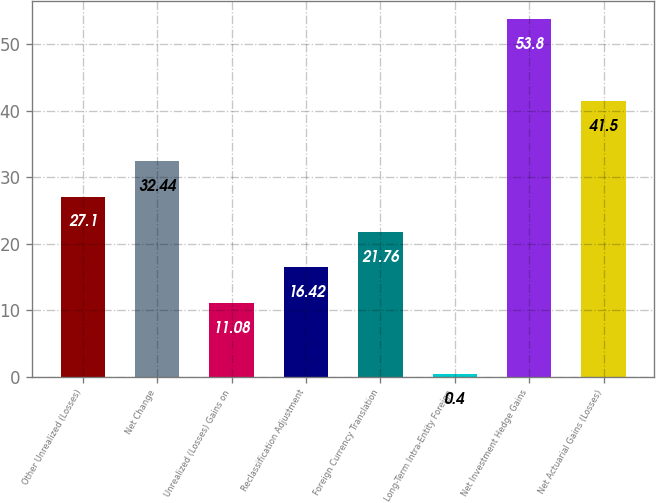<chart> <loc_0><loc_0><loc_500><loc_500><bar_chart><fcel>Other Unrealized (Losses)<fcel>Net Change<fcel>Unrealized (Losses) Gains on<fcel>Reclassification Adjustment<fcel>Foreign Currency Translation<fcel>Long-Term Intra-Entity Foreign<fcel>Net Investment Hedge Gains<fcel>Net Actuarial Gains (Losses)<nl><fcel>27.1<fcel>32.44<fcel>11.08<fcel>16.42<fcel>21.76<fcel>0.4<fcel>53.8<fcel>41.5<nl></chart> 